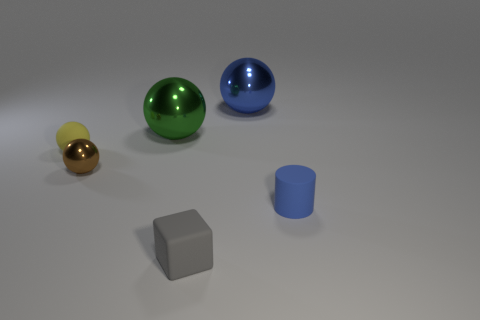There is a big thing that is the same color as the tiny matte cylinder; what is it made of?
Give a very brief answer. Metal. Does the yellow object have the same size as the blue object on the left side of the cylinder?
Provide a succinct answer. No. How many other objects are there of the same material as the tiny block?
Your answer should be compact. 2. There is a small rubber object that is behind the gray cube and to the left of the blue ball; what shape is it?
Your answer should be compact. Sphere. There is a rubber object that is on the left side of the brown metallic ball; is it the same size as the blue object left of the matte cylinder?
Provide a short and direct response. No. There is a tiny blue thing that is made of the same material as the small gray block; what is its shape?
Provide a short and direct response. Cylinder. Is there any other thing that is the same shape as the small yellow rubber object?
Keep it short and to the point. Yes. The tiny matte thing that is to the right of the sphere right of the rubber object in front of the cylinder is what color?
Offer a very short reply. Blue. Is the number of yellow rubber balls behind the green metal sphere less than the number of tiny gray matte things that are behind the matte ball?
Keep it short and to the point. No. Is the shape of the brown thing the same as the big blue metal thing?
Provide a succinct answer. Yes. 